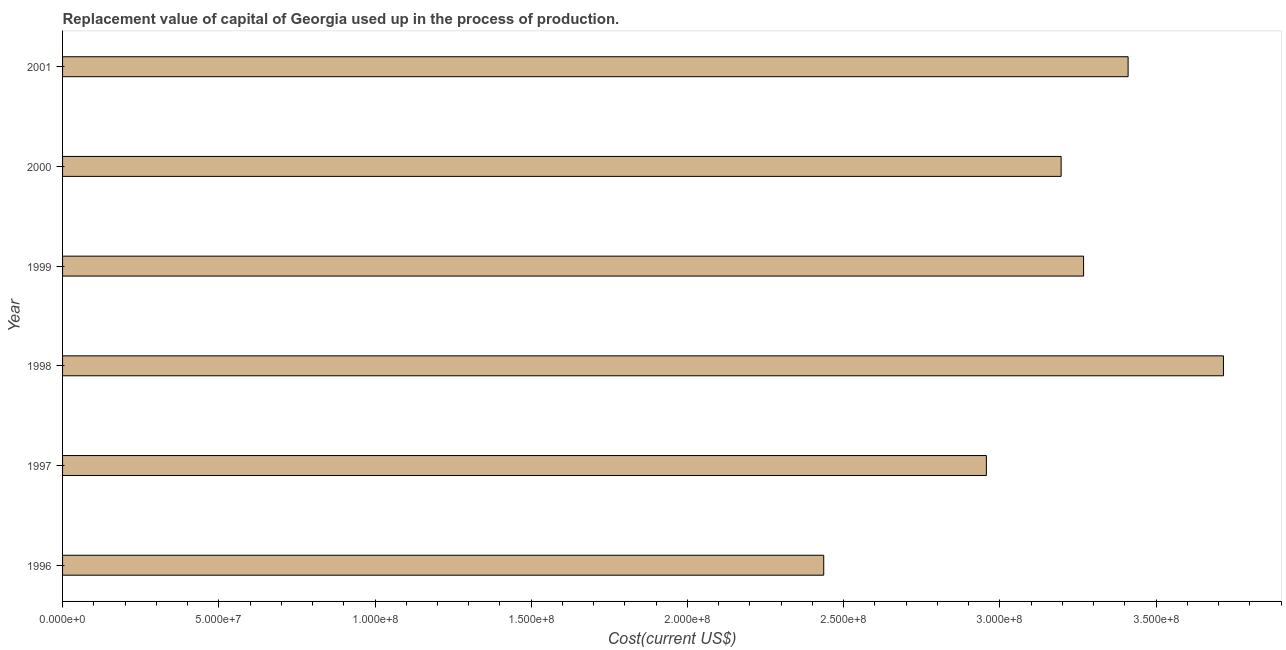Does the graph contain any zero values?
Provide a short and direct response. No. What is the title of the graph?
Your answer should be compact. Replacement value of capital of Georgia used up in the process of production. What is the label or title of the X-axis?
Offer a very short reply. Cost(current US$). What is the label or title of the Y-axis?
Offer a very short reply. Year. What is the consumption of fixed capital in 2001?
Provide a succinct answer. 3.41e+08. Across all years, what is the maximum consumption of fixed capital?
Ensure brevity in your answer.  3.72e+08. Across all years, what is the minimum consumption of fixed capital?
Keep it short and to the point. 2.44e+08. In which year was the consumption of fixed capital maximum?
Give a very brief answer. 1998. In which year was the consumption of fixed capital minimum?
Your response must be concise. 1996. What is the sum of the consumption of fixed capital?
Your response must be concise. 1.90e+09. What is the difference between the consumption of fixed capital in 1997 and 1998?
Ensure brevity in your answer.  -7.59e+07. What is the average consumption of fixed capital per year?
Keep it short and to the point. 3.16e+08. What is the median consumption of fixed capital?
Give a very brief answer. 3.23e+08. In how many years, is the consumption of fixed capital greater than 280000000 US$?
Your response must be concise. 5. Do a majority of the years between 2000 and 1996 (inclusive) have consumption of fixed capital greater than 330000000 US$?
Your answer should be compact. Yes. What is the ratio of the consumption of fixed capital in 1998 to that in 2000?
Your response must be concise. 1.16. Is the difference between the consumption of fixed capital in 1997 and 2000 greater than the difference between any two years?
Give a very brief answer. No. What is the difference between the highest and the second highest consumption of fixed capital?
Provide a short and direct response. 3.05e+07. Is the sum of the consumption of fixed capital in 1998 and 1999 greater than the maximum consumption of fixed capital across all years?
Ensure brevity in your answer.  Yes. What is the difference between the highest and the lowest consumption of fixed capital?
Provide a succinct answer. 1.28e+08. What is the difference between two consecutive major ticks on the X-axis?
Provide a short and direct response. 5.00e+07. Are the values on the major ticks of X-axis written in scientific E-notation?
Keep it short and to the point. Yes. What is the Cost(current US$) in 1996?
Keep it short and to the point. 2.44e+08. What is the Cost(current US$) in 1997?
Provide a short and direct response. 2.96e+08. What is the Cost(current US$) of 1998?
Offer a terse response. 3.72e+08. What is the Cost(current US$) in 1999?
Your answer should be very brief. 3.27e+08. What is the Cost(current US$) of 2000?
Provide a short and direct response. 3.20e+08. What is the Cost(current US$) of 2001?
Ensure brevity in your answer.  3.41e+08. What is the difference between the Cost(current US$) in 1996 and 1997?
Keep it short and to the point. -5.21e+07. What is the difference between the Cost(current US$) in 1996 and 1998?
Make the answer very short. -1.28e+08. What is the difference between the Cost(current US$) in 1996 and 1999?
Provide a succinct answer. -8.32e+07. What is the difference between the Cost(current US$) in 1996 and 2000?
Offer a terse response. -7.60e+07. What is the difference between the Cost(current US$) in 1996 and 2001?
Make the answer very short. -9.74e+07. What is the difference between the Cost(current US$) in 1997 and 1998?
Make the answer very short. -7.59e+07. What is the difference between the Cost(current US$) in 1997 and 1999?
Ensure brevity in your answer.  -3.11e+07. What is the difference between the Cost(current US$) in 1997 and 2000?
Ensure brevity in your answer.  -2.39e+07. What is the difference between the Cost(current US$) in 1997 and 2001?
Ensure brevity in your answer.  -4.54e+07. What is the difference between the Cost(current US$) in 1998 and 1999?
Offer a terse response. 4.48e+07. What is the difference between the Cost(current US$) in 1998 and 2000?
Make the answer very short. 5.20e+07. What is the difference between the Cost(current US$) in 1998 and 2001?
Your response must be concise. 3.05e+07. What is the difference between the Cost(current US$) in 1999 and 2000?
Provide a short and direct response. 7.19e+06. What is the difference between the Cost(current US$) in 1999 and 2001?
Offer a very short reply. -1.42e+07. What is the difference between the Cost(current US$) in 2000 and 2001?
Make the answer very short. -2.14e+07. What is the ratio of the Cost(current US$) in 1996 to that in 1997?
Ensure brevity in your answer.  0.82. What is the ratio of the Cost(current US$) in 1996 to that in 1998?
Offer a terse response. 0.66. What is the ratio of the Cost(current US$) in 1996 to that in 1999?
Give a very brief answer. 0.74. What is the ratio of the Cost(current US$) in 1996 to that in 2000?
Ensure brevity in your answer.  0.76. What is the ratio of the Cost(current US$) in 1996 to that in 2001?
Your answer should be compact. 0.71. What is the ratio of the Cost(current US$) in 1997 to that in 1998?
Ensure brevity in your answer.  0.8. What is the ratio of the Cost(current US$) in 1997 to that in 1999?
Offer a very short reply. 0.91. What is the ratio of the Cost(current US$) in 1997 to that in 2000?
Offer a very short reply. 0.93. What is the ratio of the Cost(current US$) in 1997 to that in 2001?
Keep it short and to the point. 0.87. What is the ratio of the Cost(current US$) in 1998 to that in 1999?
Provide a succinct answer. 1.14. What is the ratio of the Cost(current US$) in 1998 to that in 2000?
Offer a very short reply. 1.16. What is the ratio of the Cost(current US$) in 1998 to that in 2001?
Provide a short and direct response. 1.09. What is the ratio of the Cost(current US$) in 1999 to that in 2001?
Your answer should be compact. 0.96. What is the ratio of the Cost(current US$) in 2000 to that in 2001?
Your answer should be compact. 0.94. 